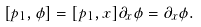<formula> <loc_0><loc_0><loc_500><loc_500>[ p _ { 1 } , \phi ] = [ p _ { 1 } , x ] \partial _ { x } \phi = \partial _ { x } \phi .</formula> 